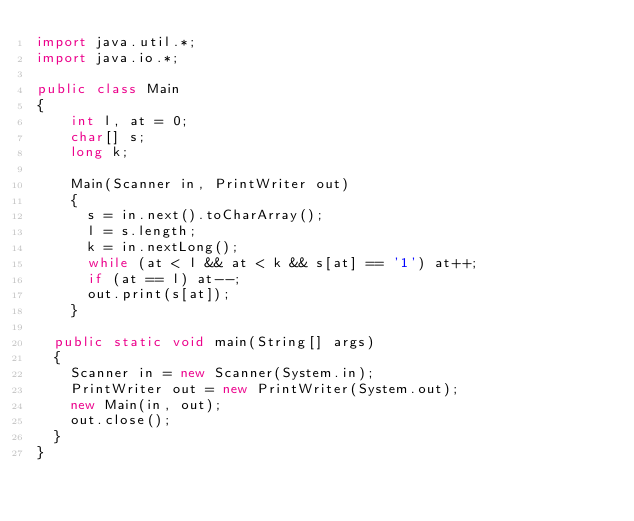Convert code to text. <code><loc_0><loc_0><loc_500><loc_500><_Java_>import java.util.*;
import java.io.*;

public class Main
{
  	int l, at = 0;
  	char[] s;
  	long k;
  
    Main(Scanner in, PrintWriter out)
    {
      s = in.next().toCharArray();
      l = s.length;
      k = in.nextLong();
      while (at < l && at < k && s[at] == '1') at++;
      if (at == l) at--;
      out.print(s[at]);
    }
	
	public static void main(String[] args)
	{
		Scanner in = new Scanner(System.in);
		PrintWriter out = new PrintWriter(System.out);
		new	Main(in, out);
		out.close();
	} 
}
</code> 